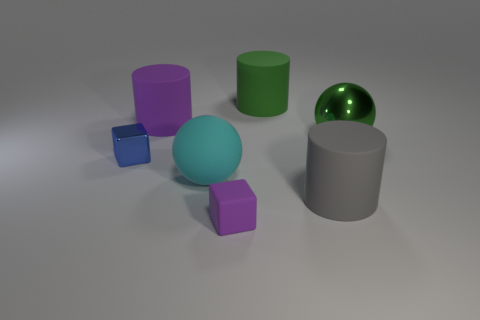Are there any green metal spheres that have the same size as the blue shiny thing?
Ensure brevity in your answer.  No. What number of things are small blue things or large cylinders?
Keep it short and to the point. 4. Is the size of the metallic thing on the right side of the large purple matte object the same as the purple rubber thing that is in front of the green ball?
Provide a short and direct response. No. Are there any other objects that have the same shape as the blue metal object?
Your answer should be compact. Yes. Is the number of large matte cylinders that are in front of the small purple block less than the number of large matte cylinders?
Provide a succinct answer. Yes. Do the tiny purple rubber thing and the blue metallic object have the same shape?
Provide a succinct answer. Yes. There is a purple thing left of the cyan sphere; what size is it?
Give a very brief answer. Large. There is a cyan thing that is made of the same material as the gray object; what is its size?
Provide a succinct answer. Large. Is the number of tiny purple matte balls less than the number of large green metal balls?
Your answer should be very brief. Yes. There is another green object that is the same size as the green shiny thing; what material is it?
Provide a succinct answer. Rubber. 